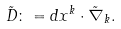Convert formula to latex. <formula><loc_0><loc_0><loc_500><loc_500>\tilde { D } \colon = d x ^ { k } \cdot \tilde { \nabla } _ { k } .</formula> 